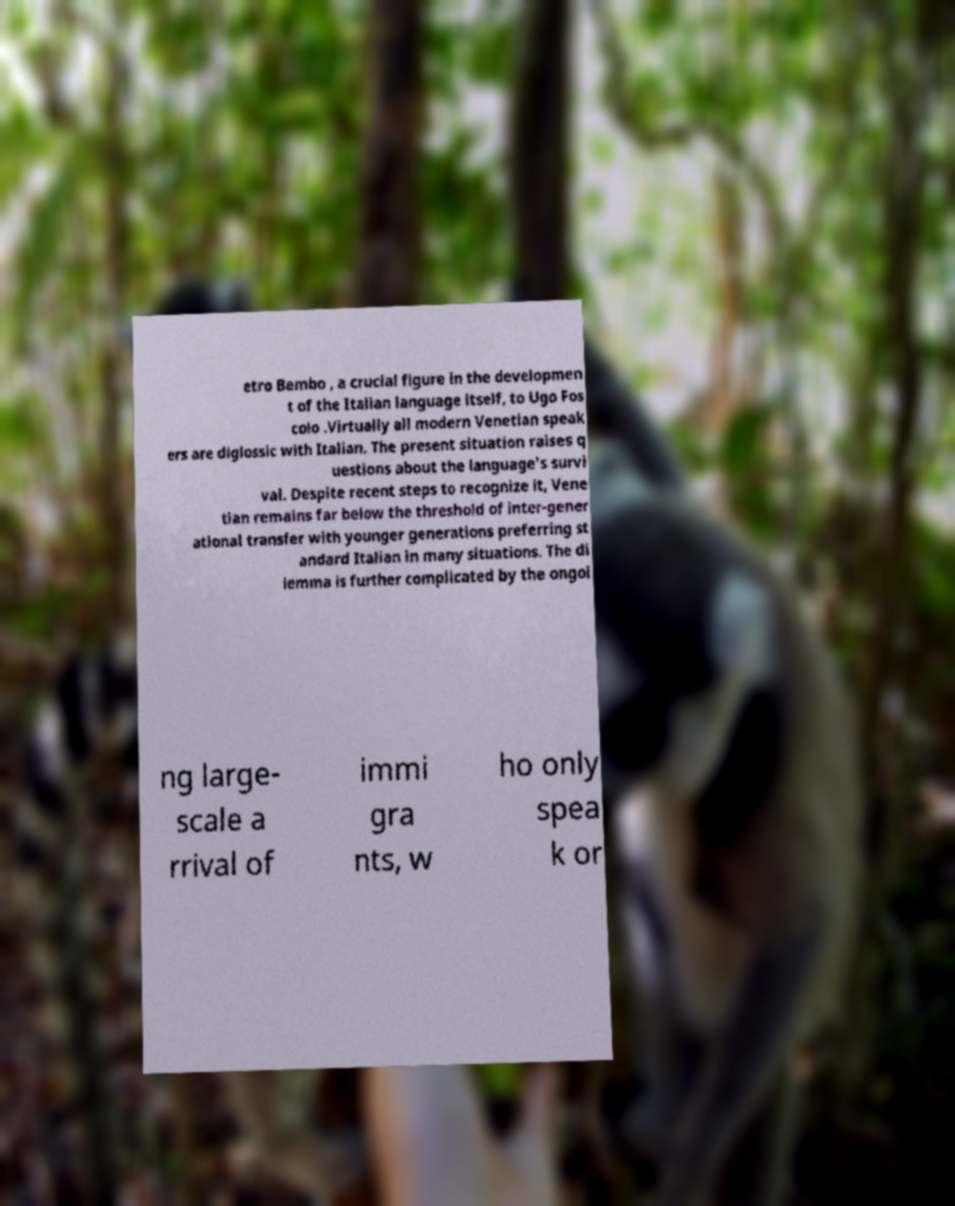For documentation purposes, I need the text within this image transcribed. Could you provide that? etro Bembo , a crucial figure in the developmen t of the Italian language itself, to Ugo Fos colo .Virtually all modern Venetian speak ers are diglossic with Italian. The present situation raises q uestions about the language's survi val. Despite recent steps to recognize it, Vene tian remains far below the threshold of inter-gener ational transfer with younger generations preferring st andard Italian in many situations. The di lemma is further complicated by the ongoi ng large- scale a rrival of immi gra nts, w ho only spea k or 